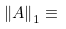Convert formula to latex. <formula><loc_0><loc_0><loc_500><loc_500>\left \| A \right \| _ { 1 } \equiv</formula> 